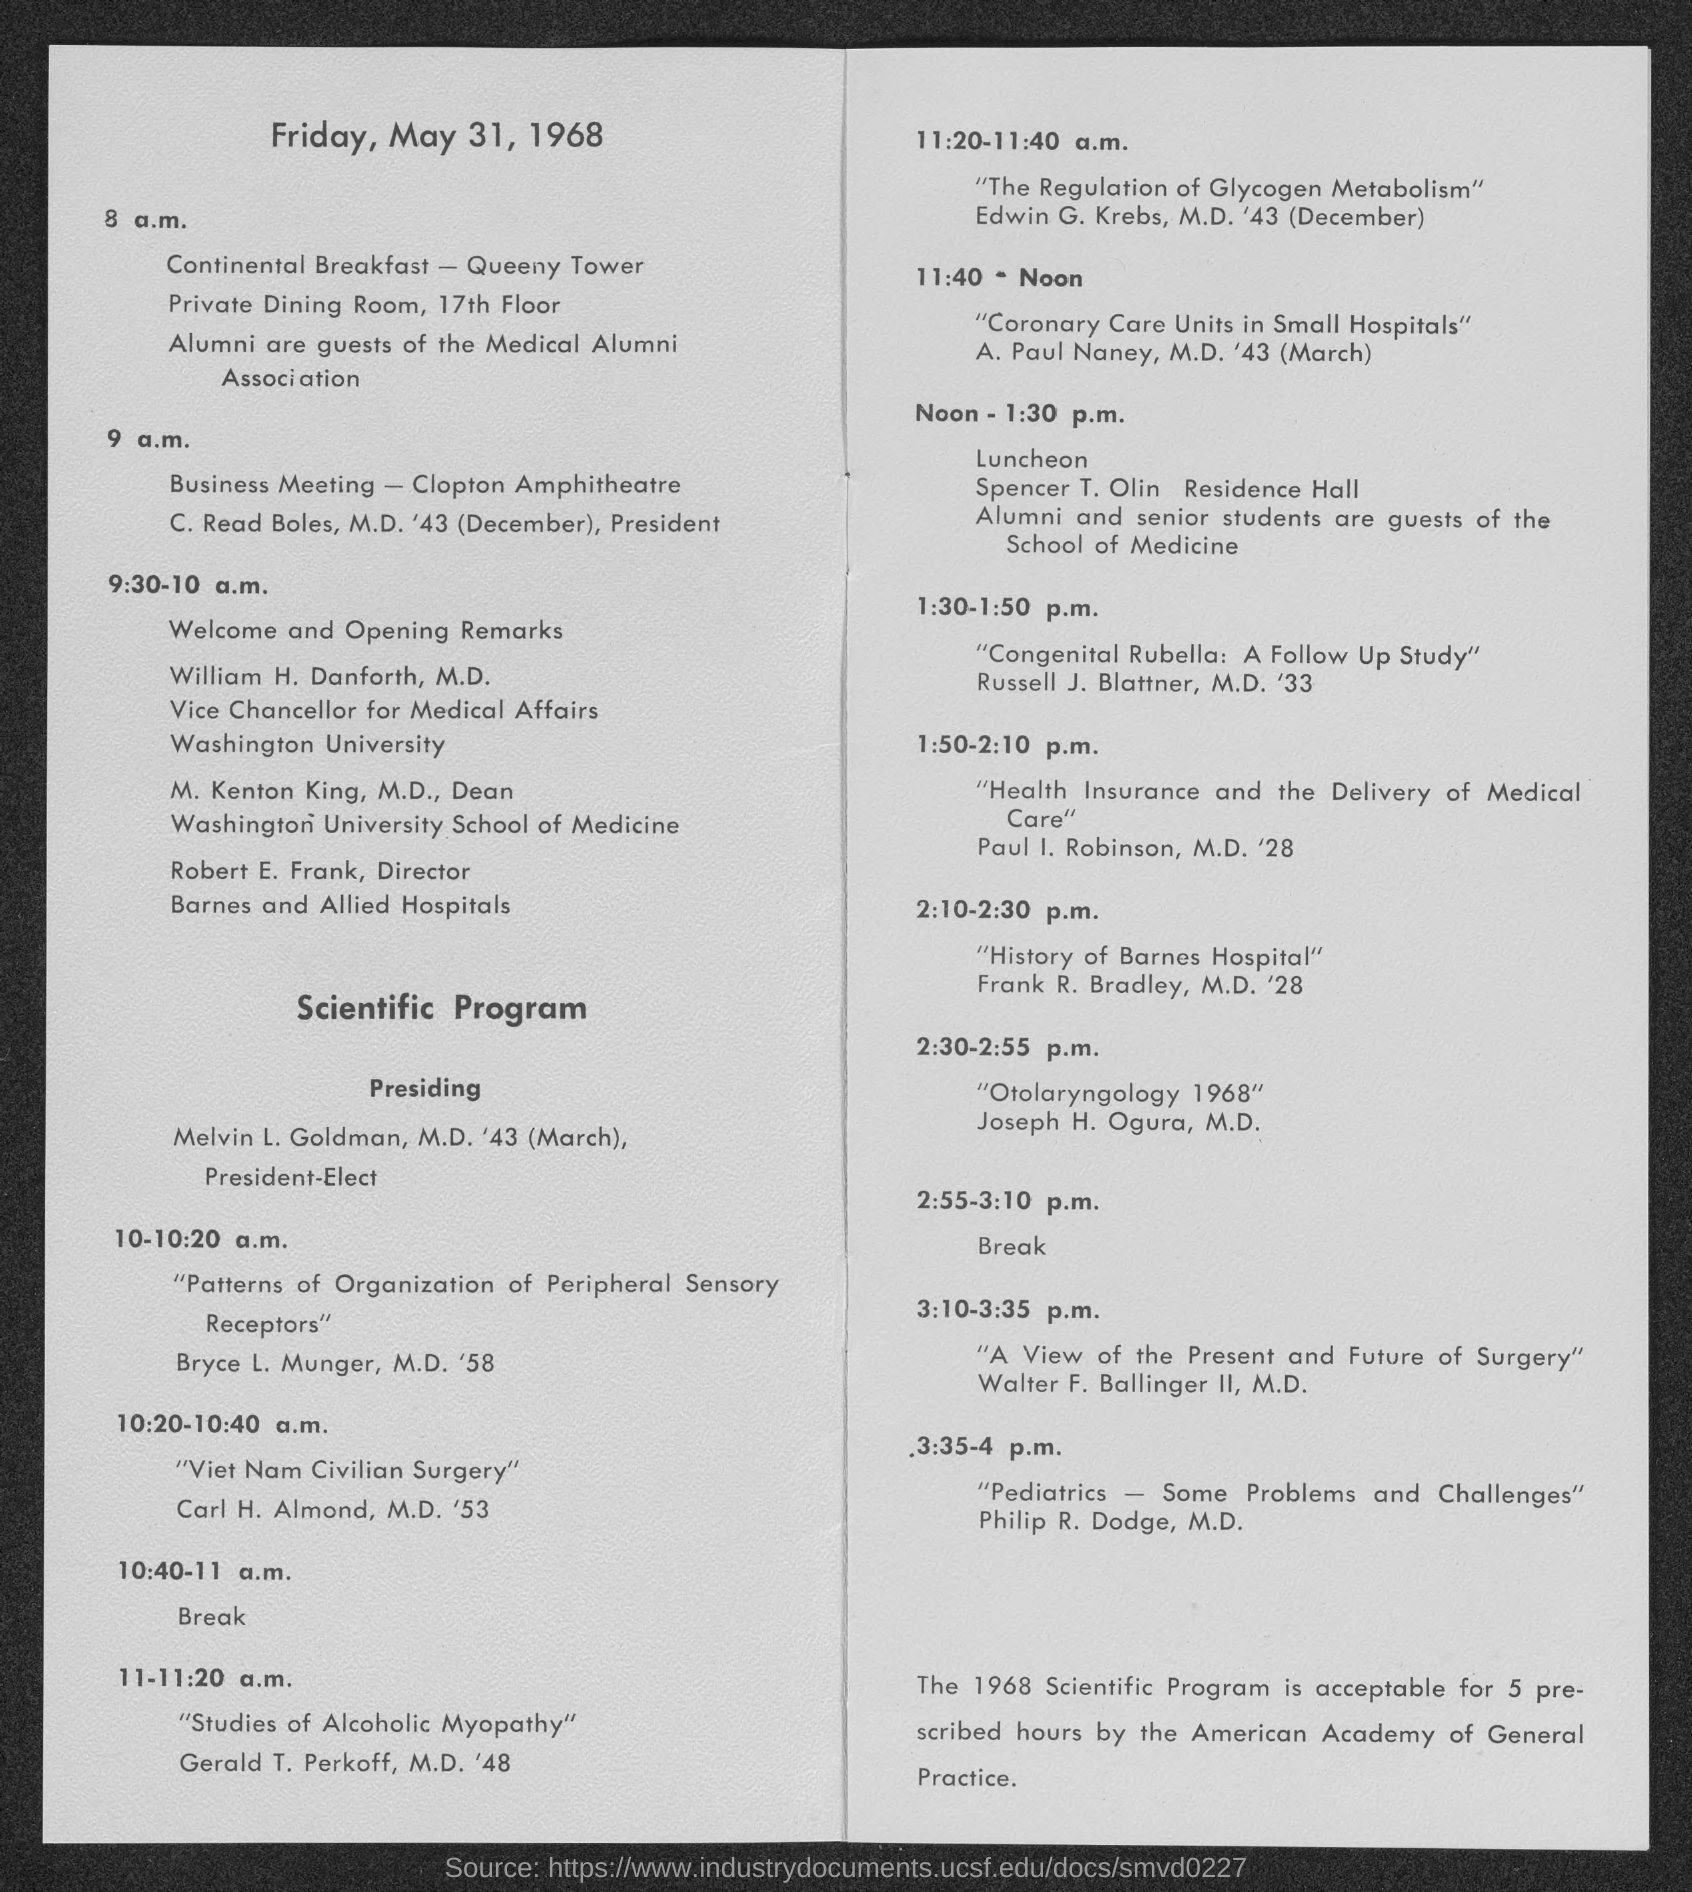What is the schedule for 10:40-11 a.m.?
Offer a terse response. Break. What is the timing for Luncheon at noon?
Make the answer very short. 1:30 p.m. 